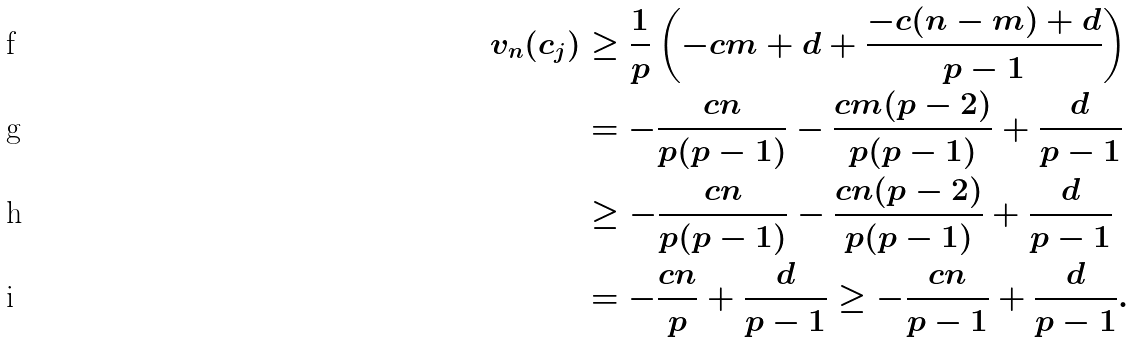Convert formula to latex. <formula><loc_0><loc_0><loc_500><loc_500>v _ { n } ( c _ { j } ) & \geq \frac { 1 } { p } \left ( - c m + d + \frac { - c ( n - m ) + d } { p - 1 } \right ) \\ & = - \frac { c n } { p ( p - 1 ) } - \frac { c m ( p - 2 ) } { p ( p - 1 ) } + \frac { d } { p - 1 } \\ & \geq - \frac { c n } { p ( p - 1 ) } - \frac { c n ( p - 2 ) } { p ( p - 1 ) } + \frac { d } { p - 1 } \\ & = - \frac { c n } { p } + \frac { d } { p - 1 } \geq - \frac { c n } { p - 1 } + \frac { d } { p - 1 } .</formula> 